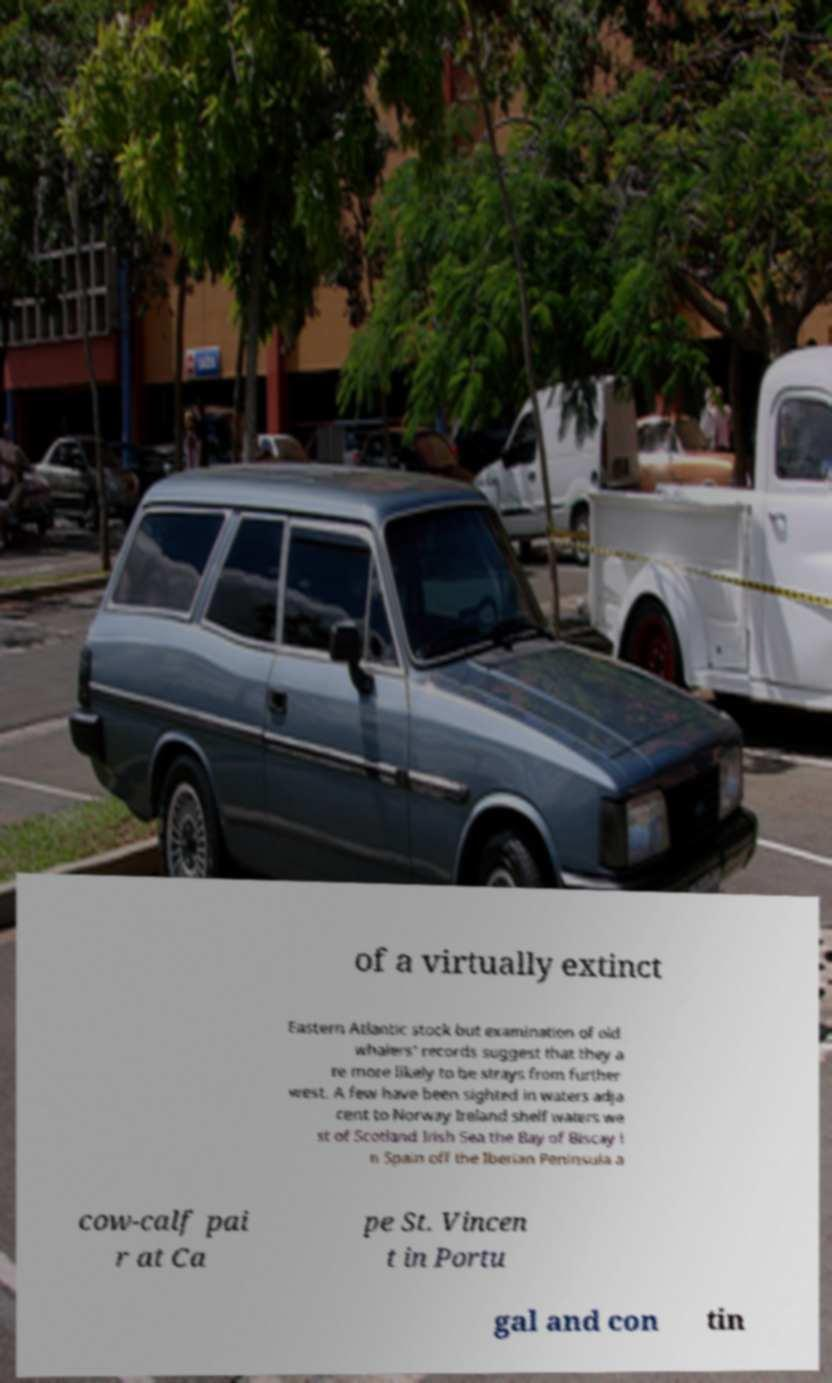For documentation purposes, I need the text within this image transcribed. Could you provide that? of a virtually extinct Eastern Atlantic stock but examination of old whalers' records suggest that they a re more likely to be strays from further west. A few have been sighted in waters adja cent to Norway Ireland shelf waters we st of Scotland Irish Sea the Bay of Biscay i n Spain off the Iberian Peninsula a cow-calf pai r at Ca pe St. Vincen t in Portu gal and con tin 